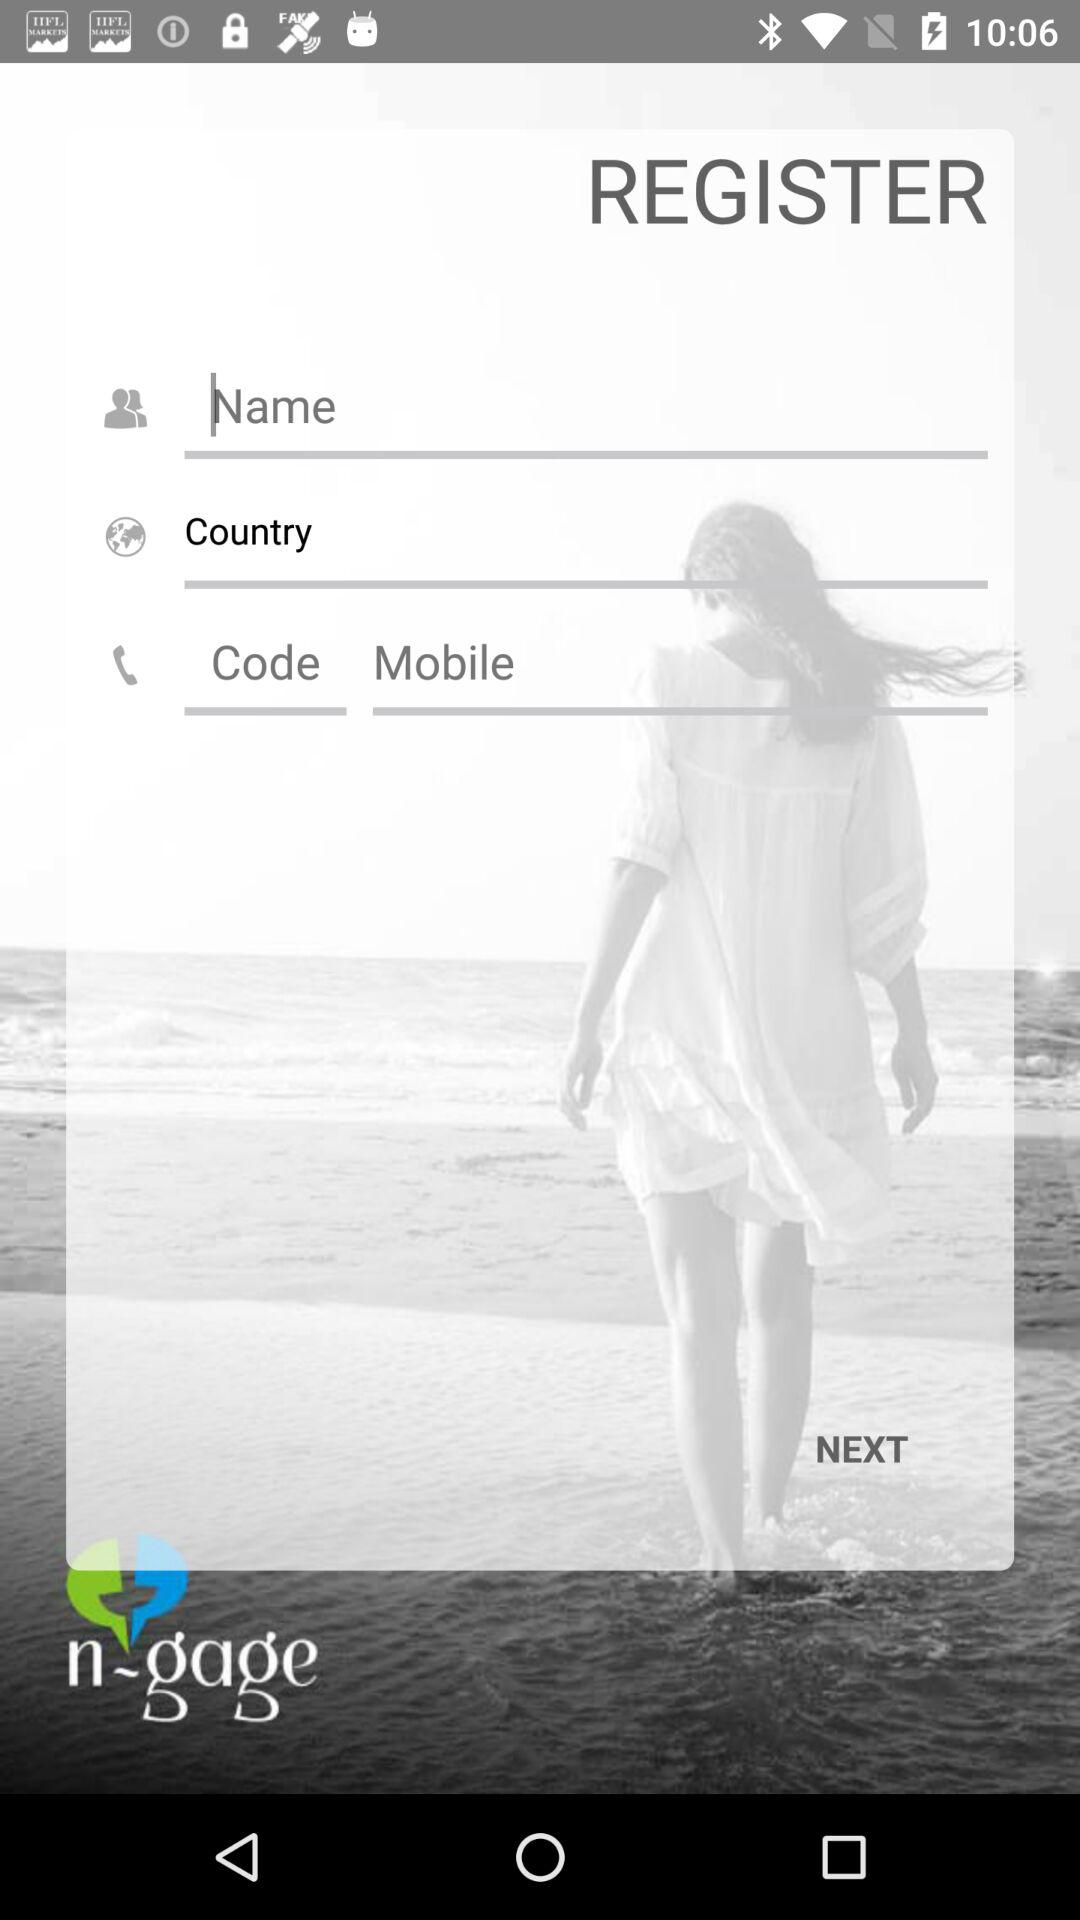What is the name of the application? The name of the application is "n-gage". 